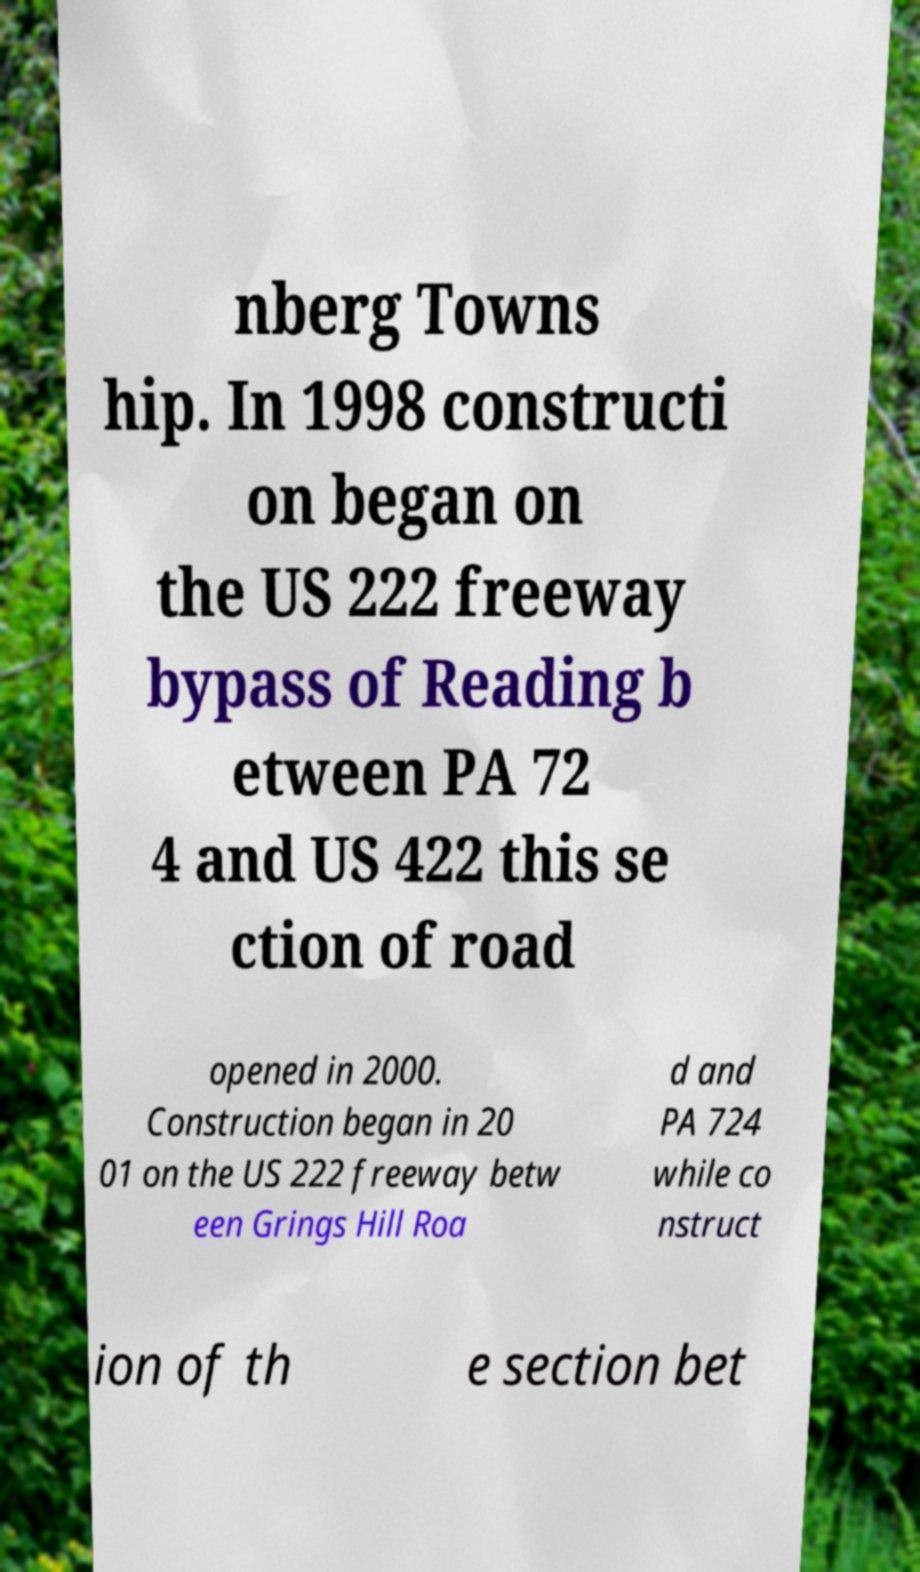Can you read and provide the text displayed in the image?This photo seems to have some interesting text. Can you extract and type it out for me? nberg Towns hip. In 1998 constructi on began on the US 222 freeway bypass of Reading b etween PA 72 4 and US 422 this se ction of road opened in 2000. Construction began in 20 01 on the US 222 freeway betw een Grings Hill Roa d and PA 724 while co nstruct ion of th e section bet 